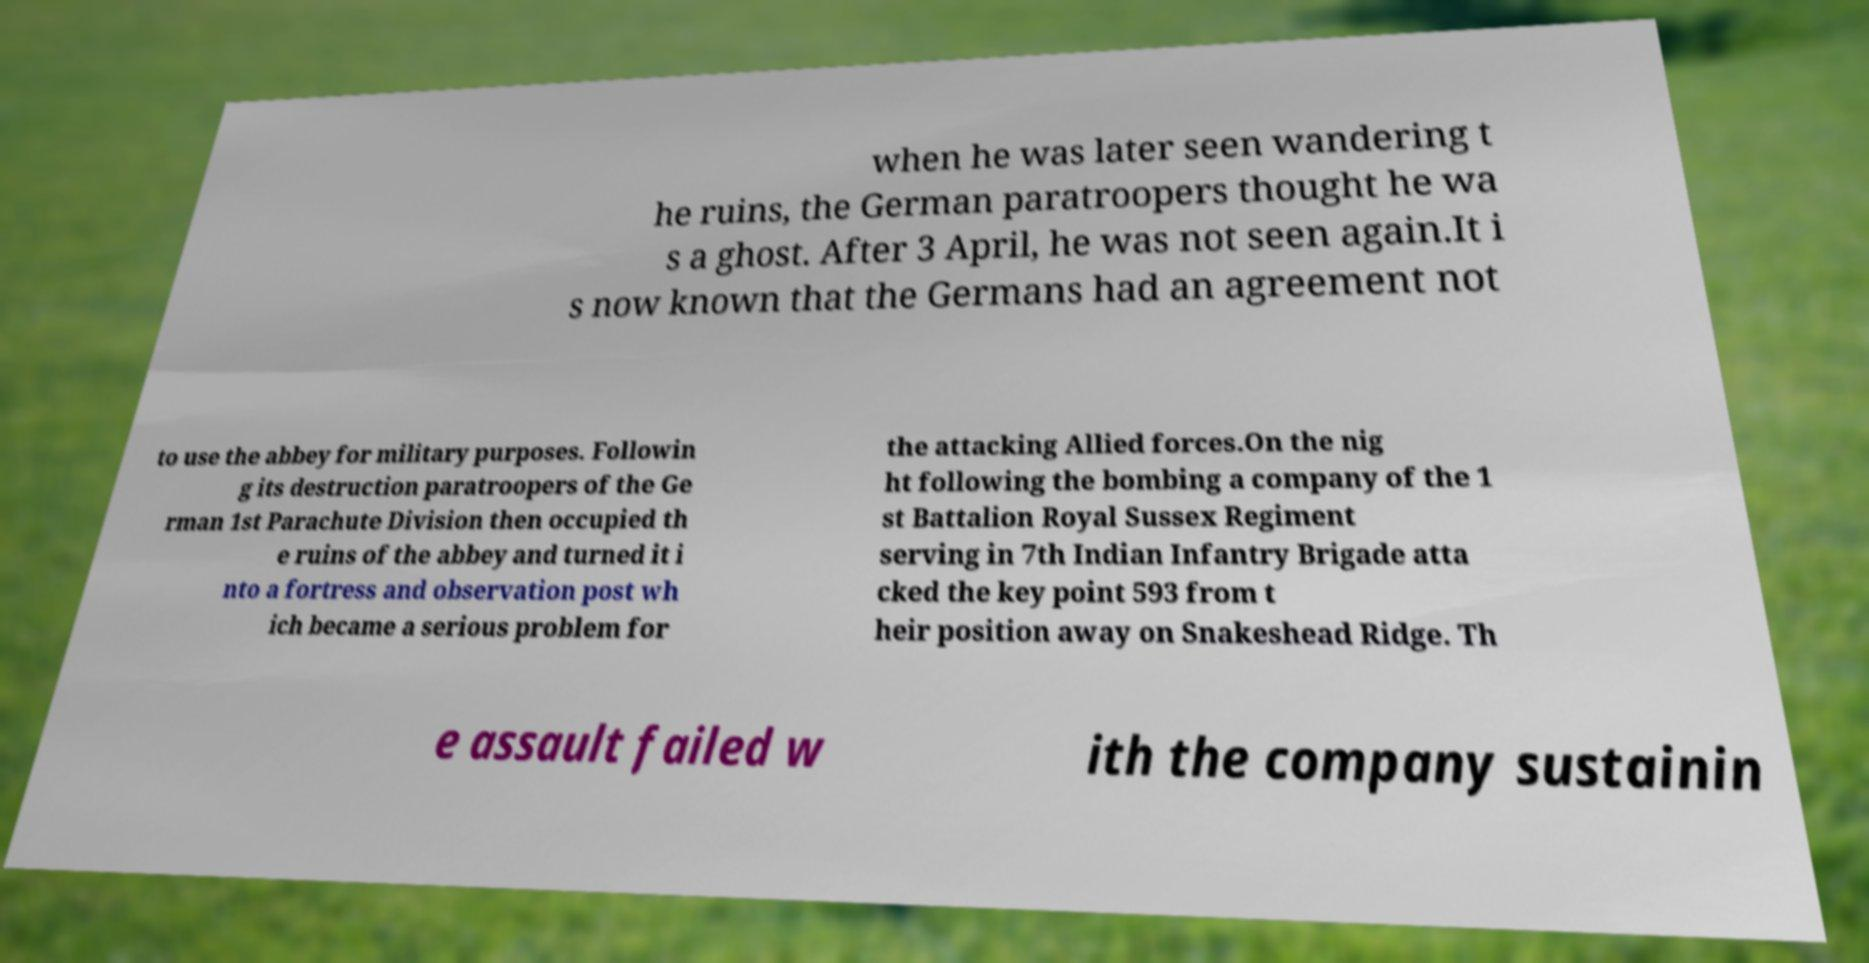Can you accurately transcribe the text from the provided image for me? when he was later seen wandering t he ruins, the German paratroopers thought he wa s a ghost. After 3 April, he was not seen again.It i s now known that the Germans had an agreement not to use the abbey for military purposes. Followin g its destruction paratroopers of the Ge rman 1st Parachute Division then occupied th e ruins of the abbey and turned it i nto a fortress and observation post wh ich became a serious problem for the attacking Allied forces.On the nig ht following the bombing a company of the 1 st Battalion Royal Sussex Regiment serving in 7th Indian Infantry Brigade atta cked the key point 593 from t heir position away on Snakeshead Ridge. Th e assault failed w ith the company sustainin 